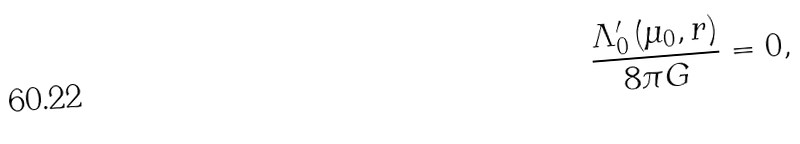<formula> <loc_0><loc_0><loc_500><loc_500>\frac { \Lambda _ { 0 } ^ { \prime } \left ( \mu _ { 0 } , r \right ) } { 8 \pi G } = 0 ,</formula> 